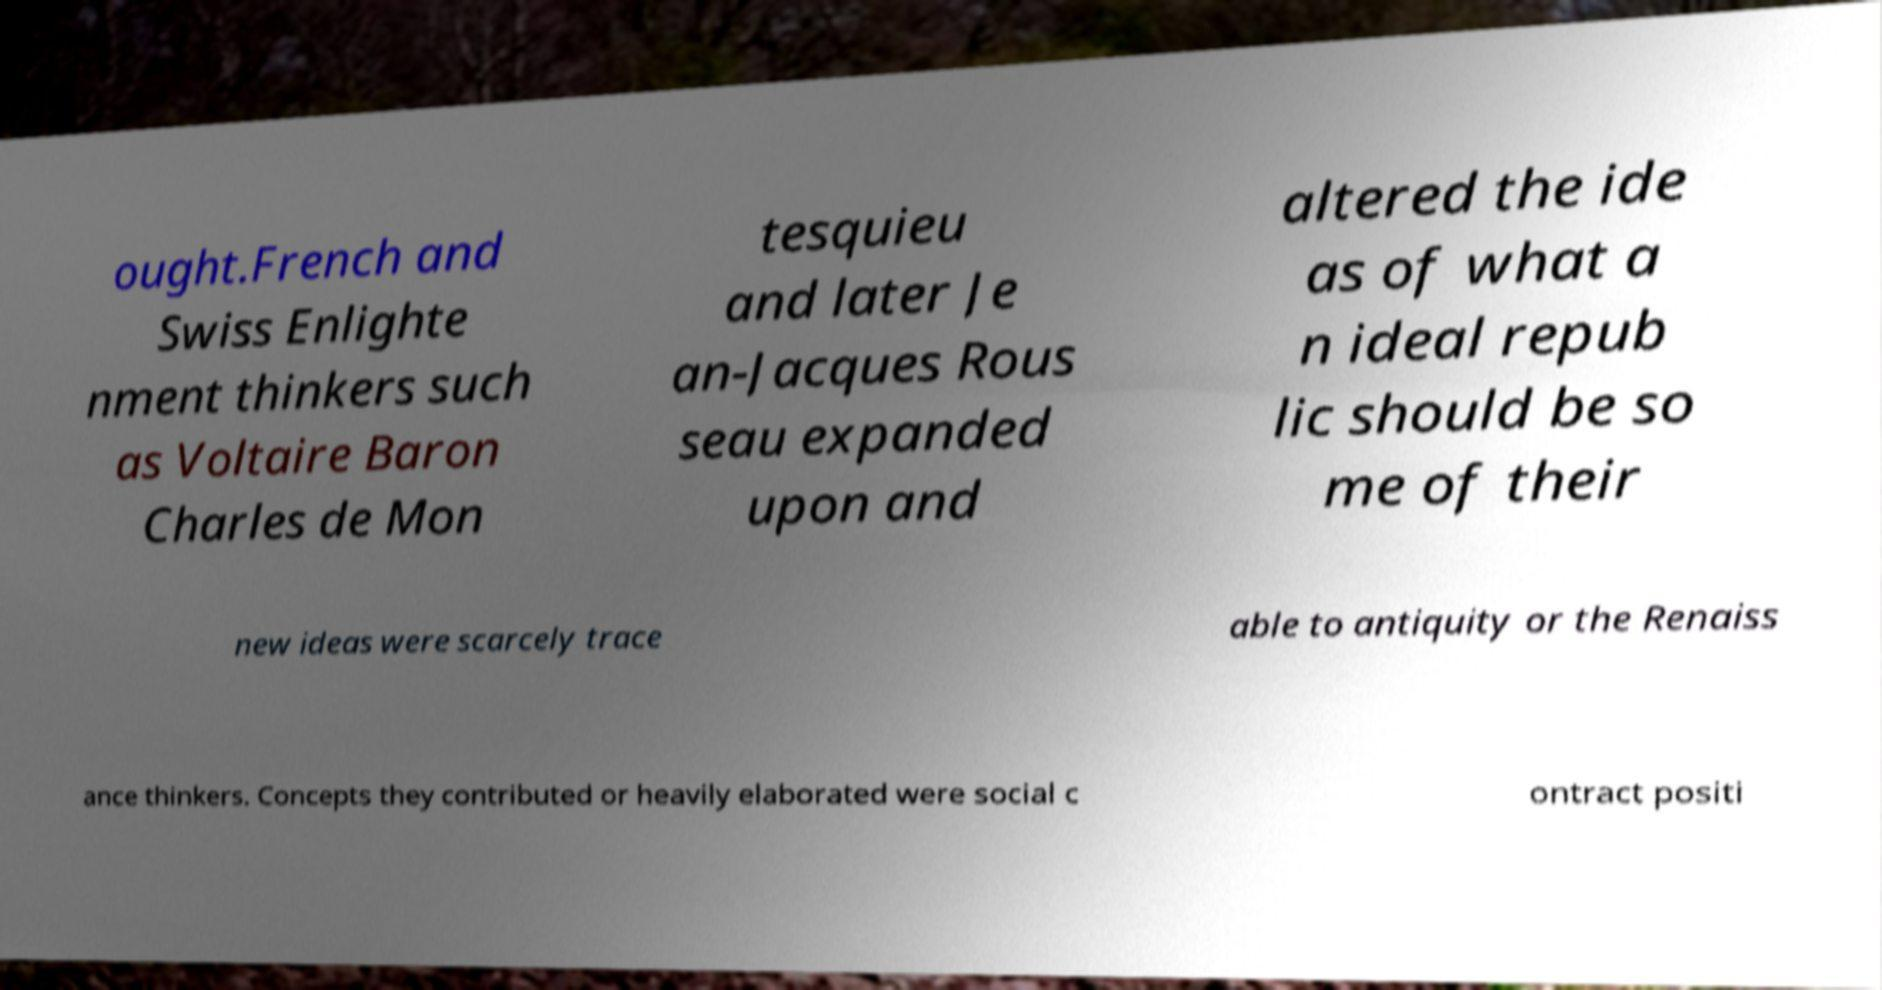Can you accurately transcribe the text from the provided image for me? ought.French and Swiss Enlighte nment thinkers such as Voltaire Baron Charles de Mon tesquieu and later Je an-Jacques Rous seau expanded upon and altered the ide as of what a n ideal repub lic should be so me of their new ideas were scarcely trace able to antiquity or the Renaiss ance thinkers. Concepts they contributed or heavily elaborated were social c ontract positi 